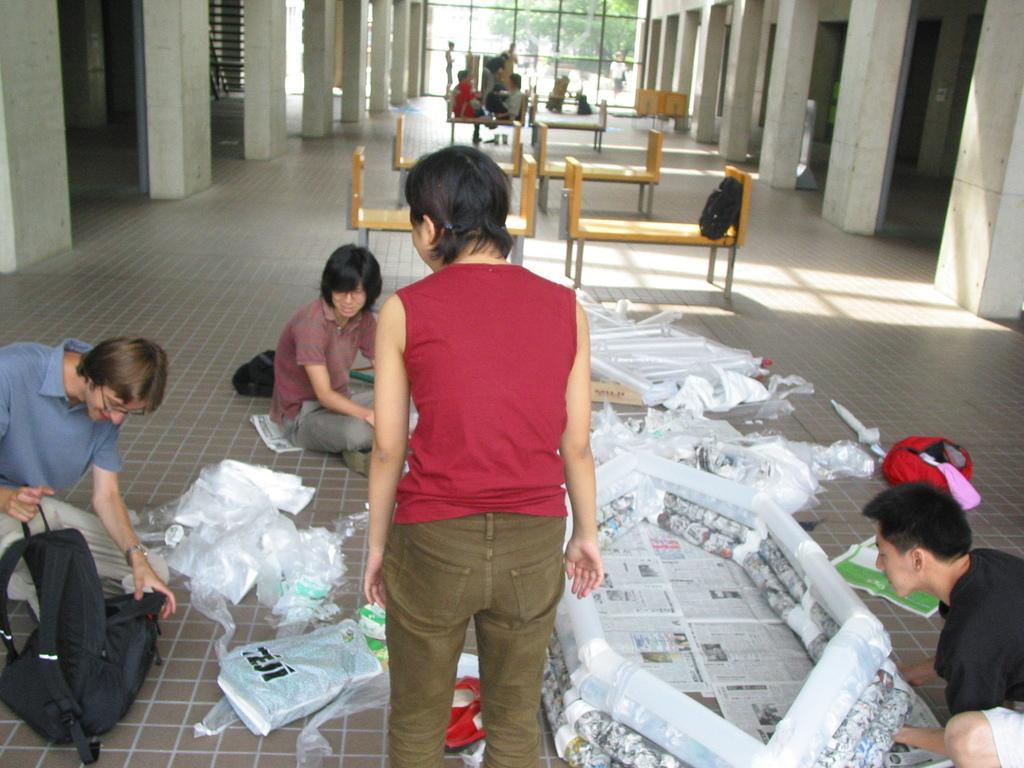Can you describe this image briefly? The picture is taken in a building. In the foreground of the picture there are newspapers, covers, bags, backpacks and people. In the center of the picture there are benches. In the background there are benches, people and glass window, outside the window there are trees. On the left and the right there are pillars and doors. 